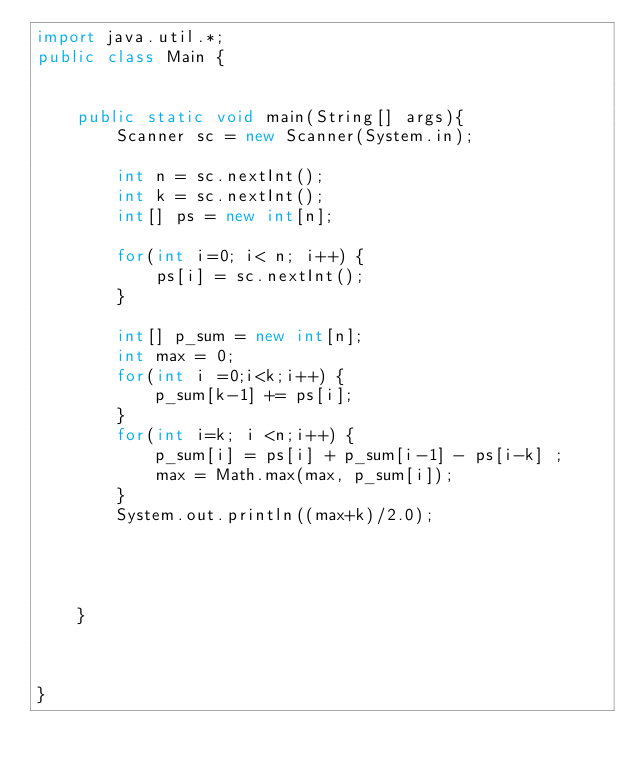<code> <loc_0><loc_0><loc_500><loc_500><_Java_>import java.util.*;
public class Main {

	
	public static void main(String[] args){
		Scanner sc = new Scanner(System.in);
		
		int n = sc.nextInt();
		int k = sc.nextInt();
		int[] ps = new int[n];
		
		for(int i=0; i< n; i++) {
			ps[i] = sc.nextInt();
		}
		
		int[] p_sum = new int[n];
		int max = 0;
		for(int i =0;i<k;i++) {
			p_sum[k-1] += ps[i];
		}
		for(int i=k; i <n;i++) {
			p_sum[i] = ps[i] + p_sum[i-1] - ps[i-k] ;
			max = Math.max(max, p_sum[i]);
		}
		System.out.println((max+k)/2.0);
		
		
		
		
	}
	


}

 </code> 